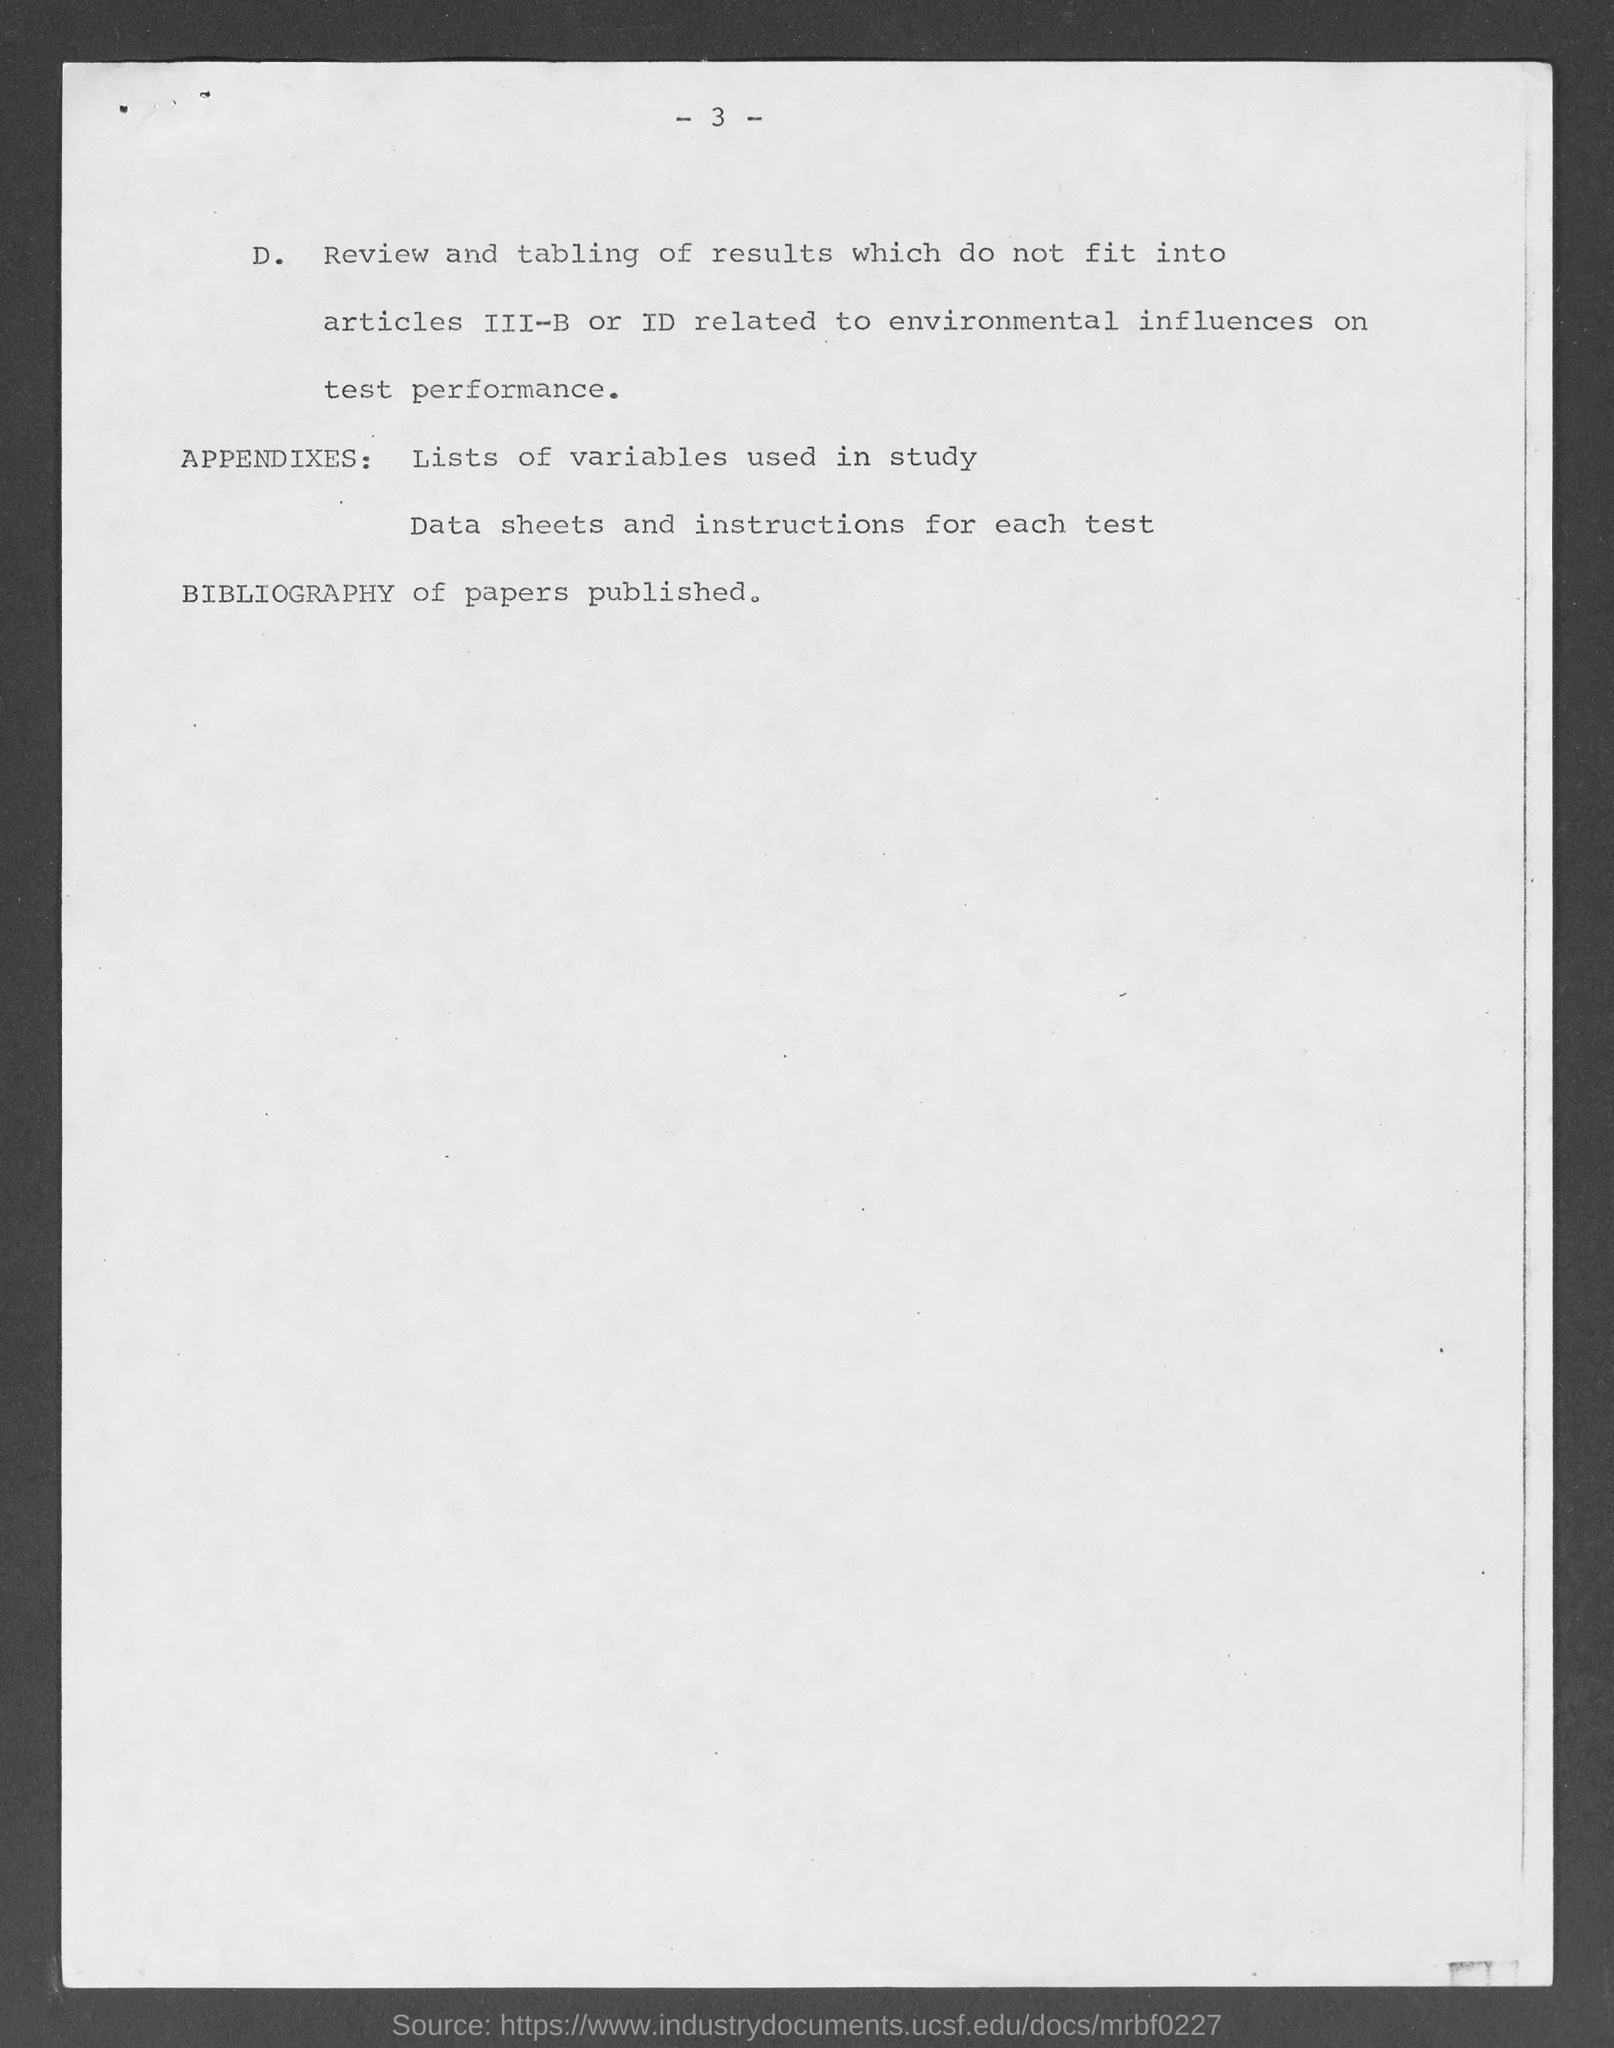What is the Page Number?
Provide a short and direct response. - 3 -. 